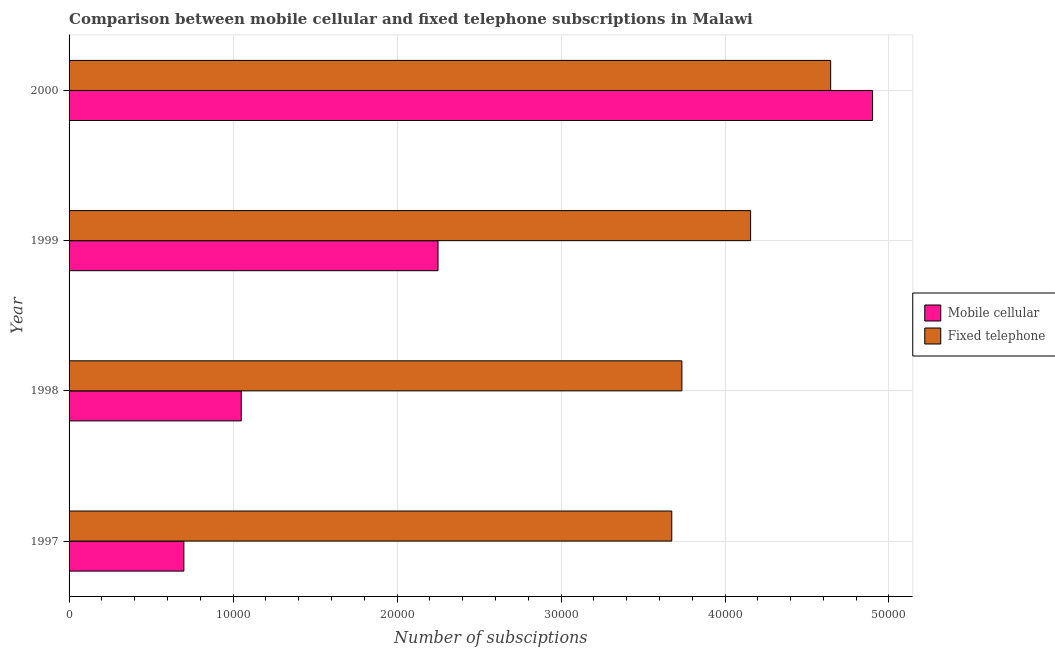How many different coloured bars are there?
Provide a succinct answer. 2. How many groups of bars are there?
Your response must be concise. 4. Are the number of bars per tick equal to the number of legend labels?
Your response must be concise. Yes. How many bars are there on the 3rd tick from the bottom?
Your answer should be compact. 2. What is the label of the 1st group of bars from the top?
Your answer should be very brief. 2000. What is the number of mobile cellular subscriptions in 1999?
Your answer should be compact. 2.25e+04. Across all years, what is the maximum number of fixed telephone subscriptions?
Your response must be concise. 4.64e+04. Across all years, what is the minimum number of mobile cellular subscriptions?
Offer a very short reply. 7000. In which year was the number of fixed telephone subscriptions maximum?
Your response must be concise. 2000. What is the total number of mobile cellular subscriptions in the graph?
Your response must be concise. 8.90e+04. What is the difference between the number of fixed telephone subscriptions in 1997 and that in 2000?
Offer a very short reply. -9690. What is the difference between the number of mobile cellular subscriptions in 1999 and the number of fixed telephone subscriptions in 1998?
Offer a very short reply. -1.49e+04. What is the average number of fixed telephone subscriptions per year?
Provide a succinct answer. 4.05e+04. In the year 1999, what is the difference between the number of fixed telephone subscriptions and number of mobile cellular subscriptions?
Give a very brief answer. 1.91e+04. In how many years, is the number of fixed telephone subscriptions greater than 34000 ?
Your answer should be very brief. 4. What is the ratio of the number of mobile cellular subscriptions in 1997 to that in 1999?
Your answer should be compact. 0.31. What is the difference between the highest and the second highest number of fixed telephone subscriptions?
Your answer should be very brief. 4882. What is the difference between the highest and the lowest number of fixed telephone subscriptions?
Make the answer very short. 9690. In how many years, is the number of mobile cellular subscriptions greater than the average number of mobile cellular subscriptions taken over all years?
Offer a terse response. 2. What does the 2nd bar from the top in 1999 represents?
Your answer should be very brief. Mobile cellular. What does the 2nd bar from the bottom in 1997 represents?
Give a very brief answer. Fixed telephone. How many bars are there?
Offer a terse response. 8. How many years are there in the graph?
Your answer should be compact. 4. Are the values on the major ticks of X-axis written in scientific E-notation?
Your answer should be very brief. No. Does the graph contain grids?
Give a very brief answer. Yes. Where does the legend appear in the graph?
Your response must be concise. Center right. How are the legend labels stacked?
Make the answer very short. Vertical. What is the title of the graph?
Offer a terse response. Comparison between mobile cellular and fixed telephone subscriptions in Malawi. What is the label or title of the X-axis?
Your response must be concise. Number of subsciptions. What is the label or title of the Y-axis?
Give a very brief answer. Year. What is the Number of subsciptions in Mobile cellular in 1997?
Your response must be concise. 7000. What is the Number of subsciptions of Fixed telephone in 1997?
Make the answer very short. 3.68e+04. What is the Number of subsciptions of Mobile cellular in 1998?
Offer a very short reply. 1.05e+04. What is the Number of subsciptions in Fixed telephone in 1998?
Give a very brief answer. 3.74e+04. What is the Number of subsciptions of Mobile cellular in 1999?
Ensure brevity in your answer.  2.25e+04. What is the Number of subsciptions in Fixed telephone in 1999?
Offer a terse response. 4.16e+04. What is the Number of subsciptions in Mobile cellular in 2000?
Keep it short and to the point. 4.90e+04. What is the Number of subsciptions in Fixed telephone in 2000?
Provide a succinct answer. 4.64e+04. Across all years, what is the maximum Number of subsciptions in Mobile cellular?
Provide a succinct answer. 4.90e+04. Across all years, what is the maximum Number of subsciptions in Fixed telephone?
Provide a succinct answer. 4.64e+04. Across all years, what is the minimum Number of subsciptions of Mobile cellular?
Your answer should be very brief. 7000. Across all years, what is the minimum Number of subsciptions in Fixed telephone?
Offer a terse response. 3.68e+04. What is the total Number of subsciptions in Mobile cellular in the graph?
Your answer should be very brief. 8.90e+04. What is the total Number of subsciptions in Fixed telephone in the graph?
Provide a succinct answer. 1.62e+05. What is the difference between the Number of subsciptions of Mobile cellular in 1997 and that in 1998?
Keep it short and to the point. -3500. What is the difference between the Number of subsciptions of Fixed telephone in 1997 and that in 1998?
Your response must be concise. -617. What is the difference between the Number of subsciptions of Mobile cellular in 1997 and that in 1999?
Offer a very short reply. -1.55e+04. What is the difference between the Number of subsciptions in Fixed telephone in 1997 and that in 1999?
Provide a succinct answer. -4808. What is the difference between the Number of subsciptions in Mobile cellular in 1997 and that in 2000?
Your answer should be compact. -4.20e+04. What is the difference between the Number of subsciptions of Fixed telephone in 1997 and that in 2000?
Make the answer very short. -9690. What is the difference between the Number of subsciptions in Mobile cellular in 1998 and that in 1999?
Offer a very short reply. -1.20e+04. What is the difference between the Number of subsciptions in Fixed telephone in 1998 and that in 1999?
Provide a succinct answer. -4191. What is the difference between the Number of subsciptions of Mobile cellular in 1998 and that in 2000?
Offer a very short reply. -3.85e+04. What is the difference between the Number of subsciptions in Fixed telephone in 1998 and that in 2000?
Ensure brevity in your answer.  -9073. What is the difference between the Number of subsciptions of Mobile cellular in 1999 and that in 2000?
Give a very brief answer. -2.65e+04. What is the difference between the Number of subsciptions of Fixed telephone in 1999 and that in 2000?
Offer a terse response. -4882. What is the difference between the Number of subsciptions in Mobile cellular in 1997 and the Number of subsciptions in Fixed telephone in 1998?
Provide a short and direct response. -3.04e+04. What is the difference between the Number of subsciptions of Mobile cellular in 1997 and the Number of subsciptions of Fixed telephone in 1999?
Keep it short and to the point. -3.46e+04. What is the difference between the Number of subsciptions in Mobile cellular in 1997 and the Number of subsciptions in Fixed telephone in 2000?
Provide a succinct answer. -3.94e+04. What is the difference between the Number of subsciptions of Mobile cellular in 1998 and the Number of subsciptions of Fixed telephone in 1999?
Keep it short and to the point. -3.11e+04. What is the difference between the Number of subsciptions in Mobile cellular in 1998 and the Number of subsciptions in Fixed telephone in 2000?
Provide a succinct answer. -3.59e+04. What is the difference between the Number of subsciptions in Mobile cellular in 1999 and the Number of subsciptions in Fixed telephone in 2000?
Ensure brevity in your answer.  -2.39e+04. What is the average Number of subsciptions of Mobile cellular per year?
Offer a very short reply. 2.22e+04. What is the average Number of subsciptions in Fixed telephone per year?
Your response must be concise. 4.05e+04. In the year 1997, what is the difference between the Number of subsciptions in Mobile cellular and Number of subsciptions in Fixed telephone?
Offer a very short reply. -2.98e+04. In the year 1998, what is the difference between the Number of subsciptions of Mobile cellular and Number of subsciptions of Fixed telephone?
Make the answer very short. -2.69e+04. In the year 1999, what is the difference between the Number of subsciptions in Mobile cellular and Number of subsciptions in Fixed telephone?
Make the answer very short. -1.91e+04. In the year 2000, what is the difference between the Number of subsciptions in Mobile cellular and Number of subsciptions in Fixed telephone?
Ensure brevity in your answer.  2556. What is the ratio of the Number of subsciptions of Fixed telephone in 1997 to that in 1998?
Your response must be concise. 0.98. What is the ratio of the Number of subsciptions of Mobile cellular in 1997 to that in 1999?
Offer a terse response. 0.31. What is the ratio of the Number of subsciptions of Fixed telephone in 1997 to that in 1999?
Provide a succinct answer. 0.88. What is the ratio of the Number of subsciptions in Mobile cellular in 1997 to that in 2000?
Give a very brief answer. 0.14. What is the ratio of the Number of subsciptions in Fixed telephone in 1997 to that in 2000?
Offer a very short reply. 0.79. What is the ratio of the Number of subsciptions in Mobile cellular in 1998 to that in 1999?
Your answer should be very brief. 0.47. What is the ratio of the Number of subsciptions in Fixed telephone in 1998 to that in 1999?
Offer a terse response. 0.9. What is the ratio of the Number of subsciptions of Mobile cellular in 1998 to that in 2000?
Your answer should be compact. 0.21. What is the ratio of the Number of subsciptions in Fixed telephone in 1998 to that in 2000?
Your answer should be compact. 0.8. What is the ratio of the Number of subsciptions in Mobile cellular in 1999 to that in 2000?
Your response must be concise. 0.46. What is the ratio of the Number of subsciptions of Fixed telephone in 1999 to that in 2000?
Your answer should be very brief. 0.89. What is the difference between the highest and the second highest Number of subsciptions in Mobile cellular?
Provide a succinct answer. 2.65e+04. What is the difference between the highest and the second highest Number of subsciptions in Fixed telephone?
Your response must be concise. 4882. What is the difference between the highest and the lowest Number of subsciptions in Mobile cellular?
Offer a very short reply. 4.20e+04. What is the difference between the highest and the lowest Number of subsciptions of Fixed telephone?
Offer a very short reply. 9690. 